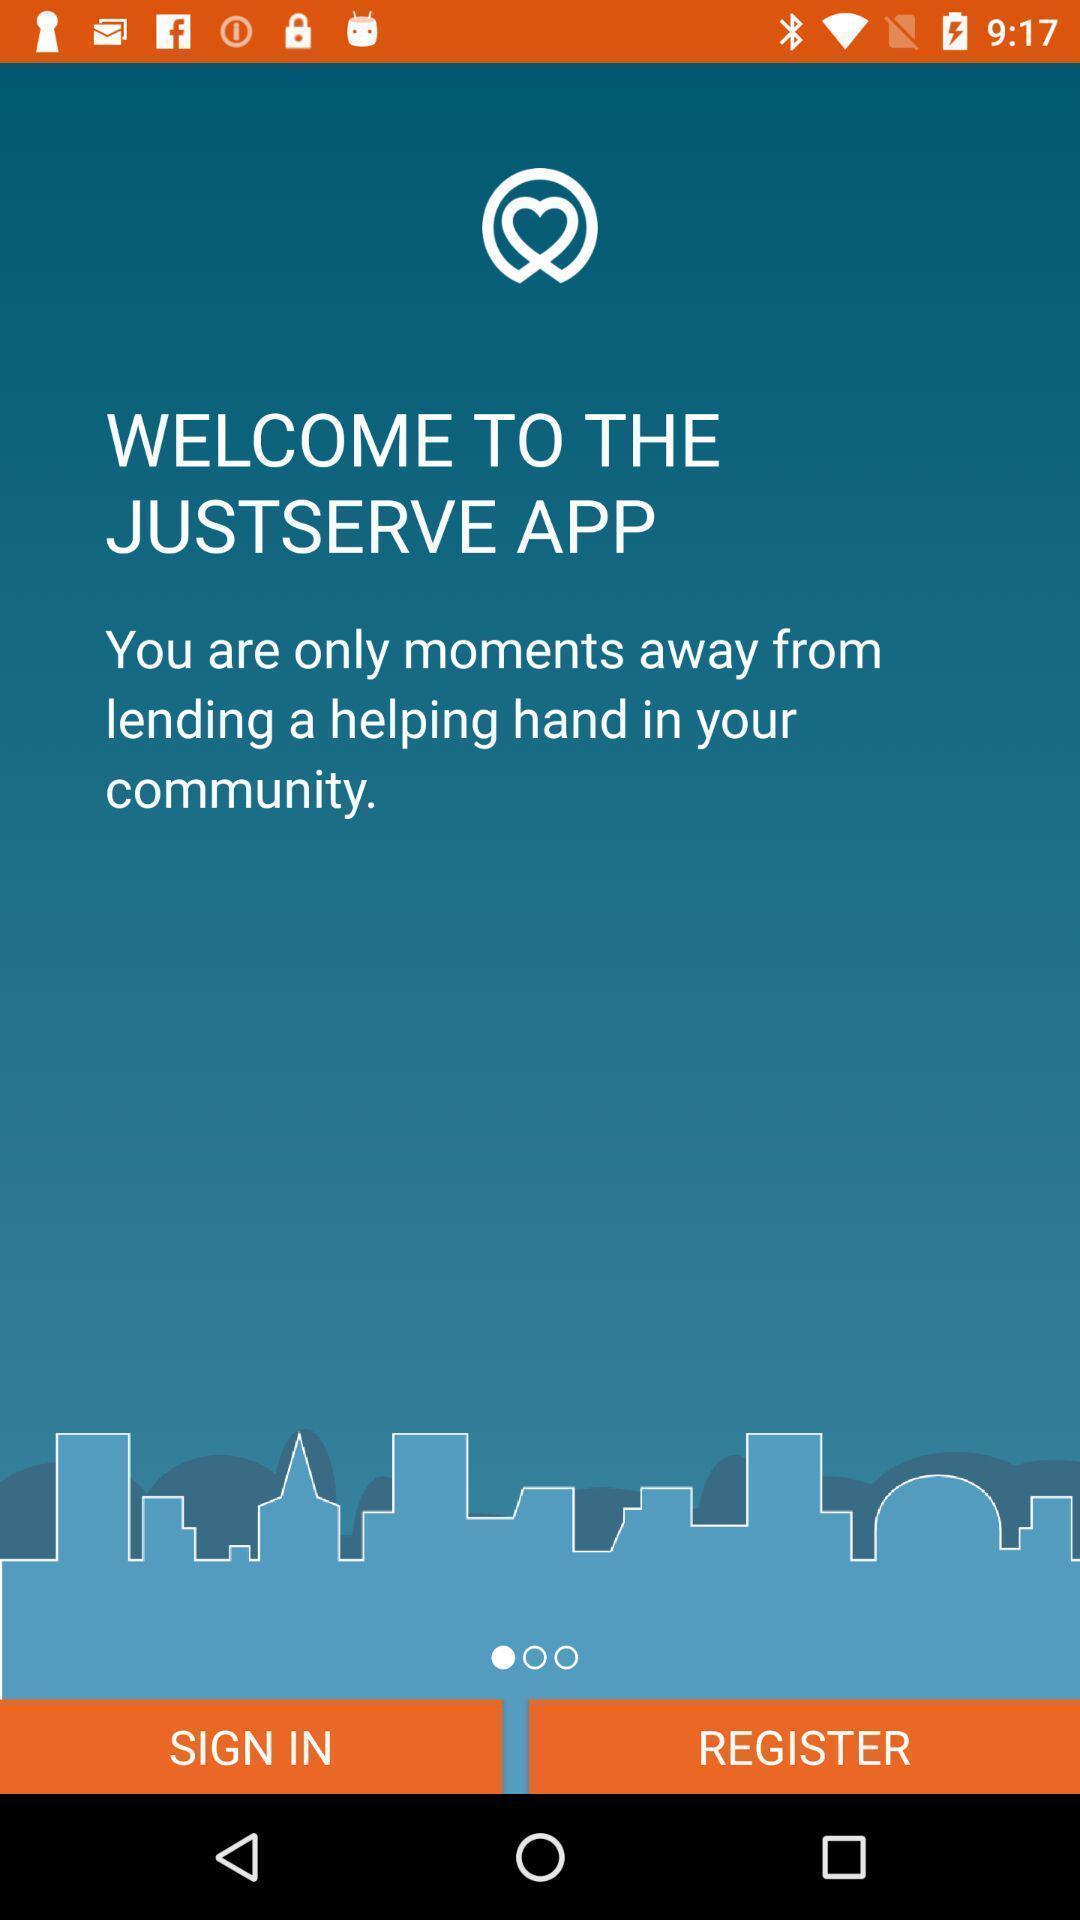Describe the visual elements of this screenshot. Welcome page of a community app. 